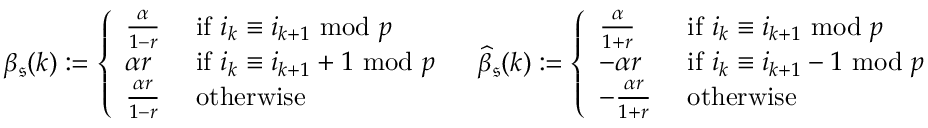Convert formula to latex. <formula><loc_0><loc_0><loc_500><loc_500>\begin{array} { r l r } & { \beta _ { \mathfrak { s } } ( k ) \colon = \left \{ \begin{array} { l l } { \frac { \alpha } { 1 - r } } & { i f i _ { k } \equiv i _ { k + 1 } \, m o d \, p } \\ { \alpha r } & { i f i _ { k } \equiv i _ { k + 1 } + 1 \, m o d \, p } \\ { \frac { \alpha r } { 1 - r } } & { o t h e r w i s e } \end{array} } & { \widehat { \beta } _ { \mathfrak { s } } ( k ) \colon = \left \{ \begin{array} { l l } { \frac { \alpha } { 1 + r } } & { i f i _ { k } \equiv i _ { k + 1 } \, m o d \, p } \\ { - \alpha r } & { i f i _ { k } \equiv i _ { k + 1 } - 1 \, m o d \, p } \\ { - \frac { \alpha r } { 1 + r } } & { o t h e r w i s e } \end{array} } \end{array}</formula> 